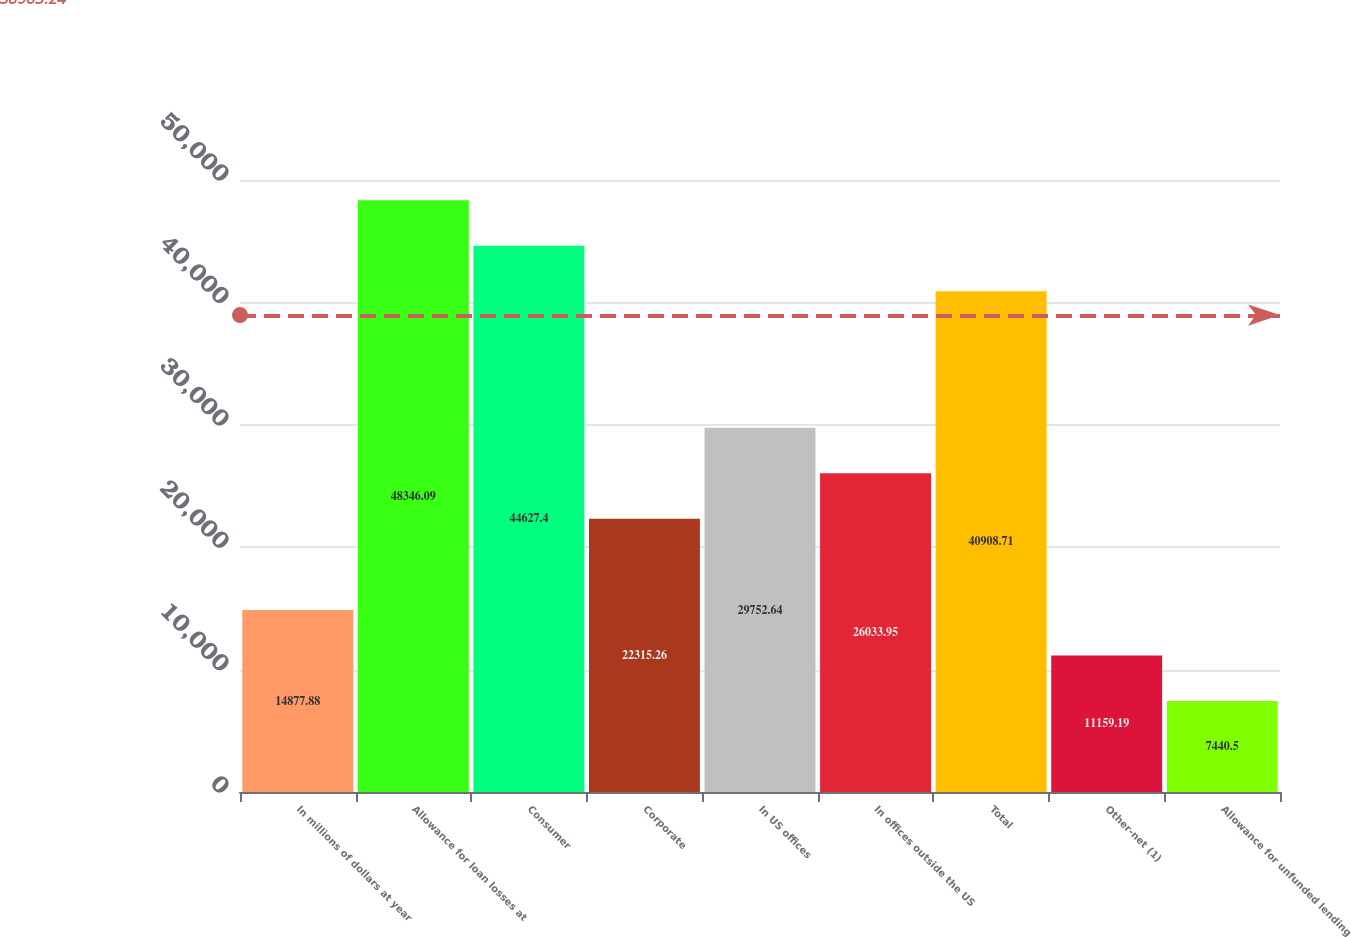<chart> <loc_0><loc_0><loc_500><loc_500><bar_chart><fcel>In millions of dollars at year<fcel>Allowance for loan losses at<fcel>Consumer<fcel>Corporate<fcel>In US offices<fcel>In offices outside the US<fcel>Total<fcel>Other-net (1)<fcel>Allowance for unfunded lending<nl><fcel>14877.9<fcel>48346.1<fcel>44627.4<fcel>22315.3<fcel>29752.6<fcel>26034<fcel>40908.7<fcel>11159.2<fcel>7440.5<nl></chart> 